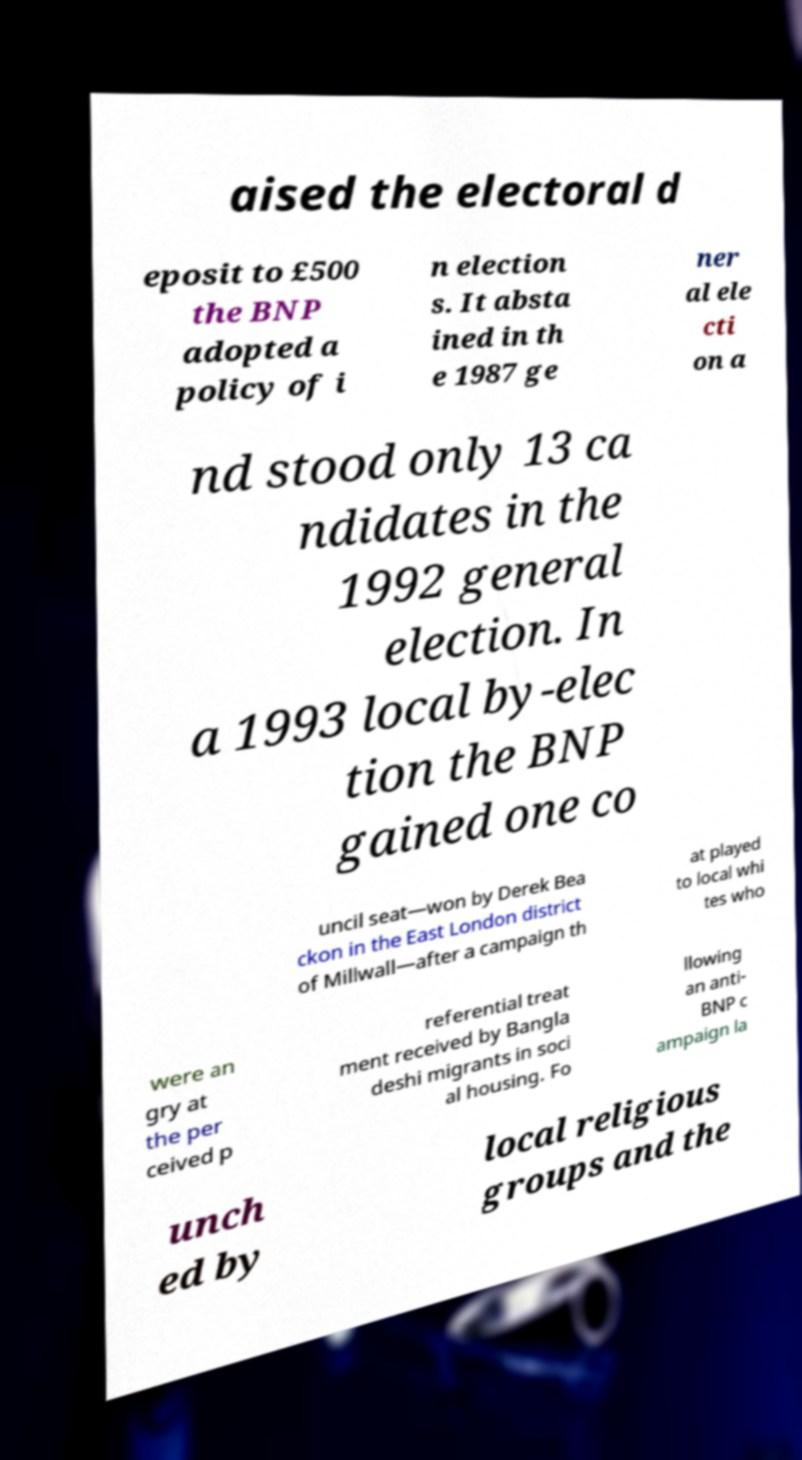Can you accurately transcribe the text from the provided image for me? aised the electoral d eposit to £500 the BNP adopted a policy of i n election s. It absta ined in th e 1987 ge ner al ele cti on a nd stood only 13 ca ndidates in the 1992 general election. In a 1993 local by-elec tion the BNP gained one co uncil seat—won by Derek Bea ckon in the East London district of Millwall—after a campaign th at played to local whi tes who were an gry at the per ceived p referential treat ment received by Bangla deshi migrants in soci al housing. Fo llowing an anti- BNP c ampaign la unch ed by local religious groups and the 